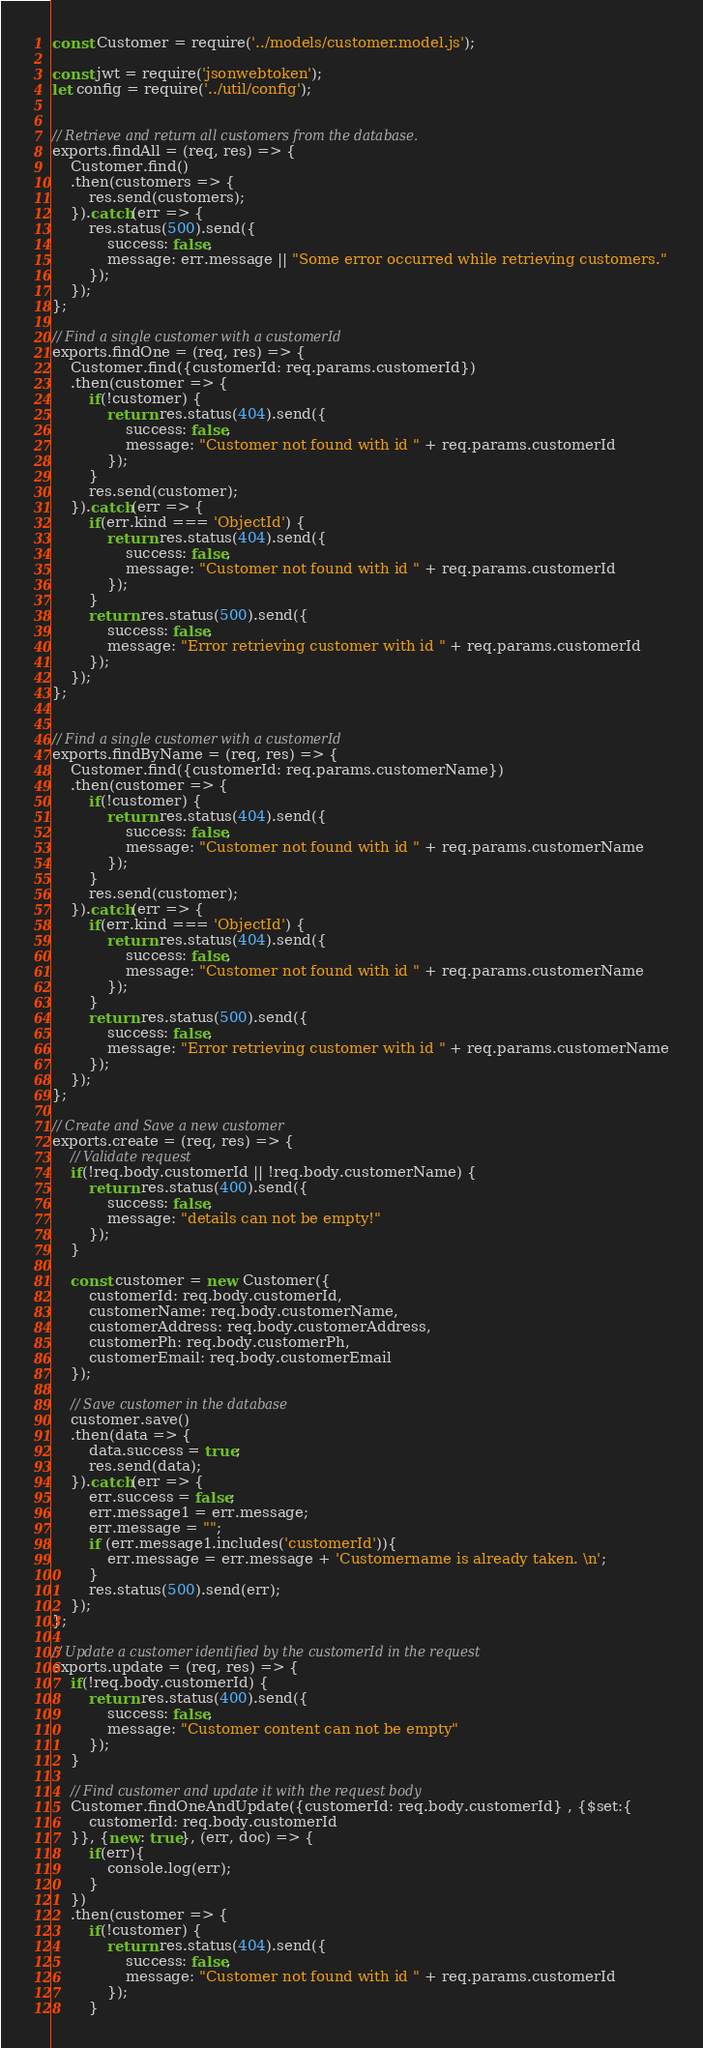Convert code to text. <code><loc_0><loc_0><loc_500><loc_500><_JavaScript_>const Customer = require('../models/customer.model.js');

const jwt = require('jsonwebtoken');
let config = require('../util/config');


// Retrieve and return all customers from the database.
exports.findAll = (req, res) => {
    Customer.find()
    .then(customers => {
        res.send(customers);
    }).catch(err => {
        res.status(500).send({
            success: false,
            message: err.message || "Some error occurred while retrieving customers."
        });
    });
};

// Find a single customer with a customerId
exports.findOne = (req, res) => {
    Customer.find({customerId: req.params.customerId})
    .then(customer => {
        if(!customer) {
            return res.status(404).send({
                success: false,
                message: "Customer not found with id " + req.params.customerId
            });            
        }
        res.send(customer);
    }).catch(err => {
        if(err.kind === 'ObjectId') {
            return res.status(404).send({
                success: false,
                message: "Customer not found with id " + req.params.customerId
            });                
        }
        return res.status(500).send({
            success: false,
            message: "Error retrieving customer with id " + req.params.customerId
        });
    });
};


// Find a single customer with a customerId
exports.findByName = (req, res) => {
    Customer.find({customerId: req.params.customerName})
    .then(customer => {
        if(!customer) {
            return res.status(404).send({
                success: false,
                message: "Customer not found with id " + req.params.customerName
            });            
        }
        res.send(customer);
    }).catch(err => {
        if(err.kind === 'ObjectId') {
            return res.status(404).send({
                success: false,
                message: "Customer not found with id " + req.params.customerName
            });                
        }
        return res.status(500).send({
            success: false,
            message: "Error retrieving customer with id " + req.params.customerName
        });
    });
};

// Create and Save a new customer
exports.create = (req, res) => {
    // Validate request
    if(!req.body.customerId || !req.body.customerName) {
        return res.status(400).send({
            success: false,
            message: "details can not be empty!"
        });
    }

    const customer = new Customer({
        customerId: req.body.customerId,
        customerName: req.body.customerName,
        customerAddress: req.body.customerAddress,
        customerPh: req.body.customerPh,
        customerEmail: req.body.customerEmail
    });

    // Save customer in the database
    customer.save()
    .then(data => {
        data.success = true;
        res.send(data);
    }).catch(err => {
        err.success = false;
        err.message1 = err.message;
        err.message = "";
        if (err.message1.includes('customerId')){
            err.message = err.message + 'Customername is already taken. \n';
        }
        res.status(500).send(err);
    });
};

// Update a customer identified by the customerId in the request
exports.update = (req, res) => {
    if(!req.body.customerId) {
        return res.status(400).send({
            success: false,
            message: "Customer content can not be empty"
        });
    }

    // Find customer and update it with the request body
    Customer.findOneAndUpdate({customerId: req.body.customerId} , {$set:{
        customerId: req.body.customerId
    }}, {new: true}, (err, doc) => {
        if(err){
            console.log(err);
        }
    })
    .then(customer => {
        if(!customer) {
            return res.status(404).send({
                success: false,
                message: "Customer not found with id " + req.params.customerId
            });
        }</code> 